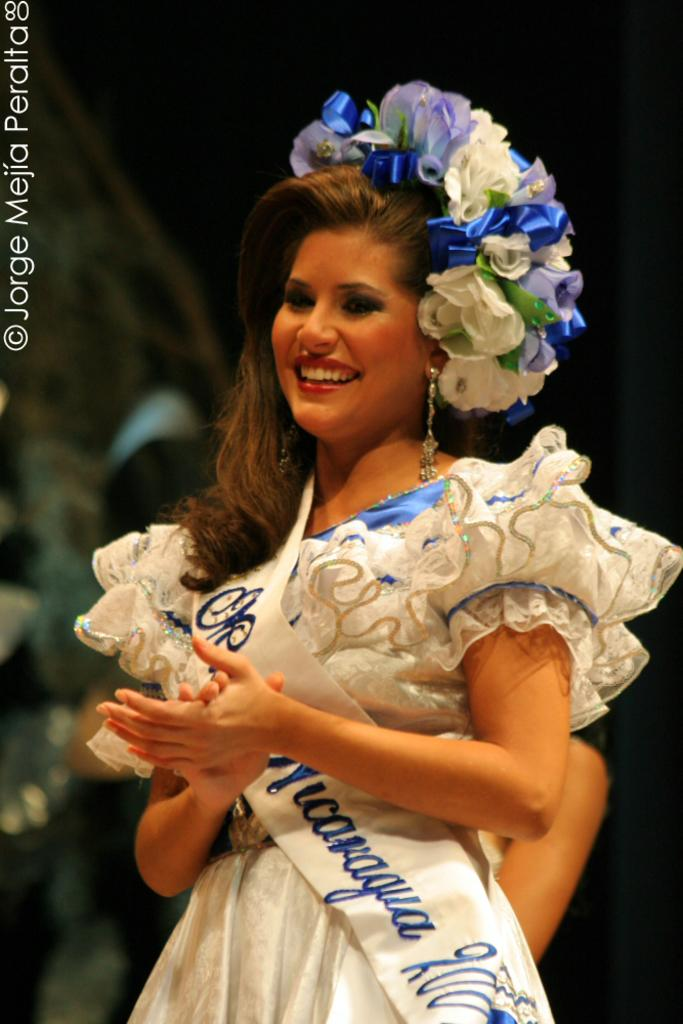<image>
Create a compact narrative representing the image presented. woman in elegant costume with miss Nicaragua sash and photo copyrighted by jorge mejia peralta 